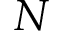Convert formula to latex. <formula><loc_0><loc_0><loc_500><loc_500>N</formula> 